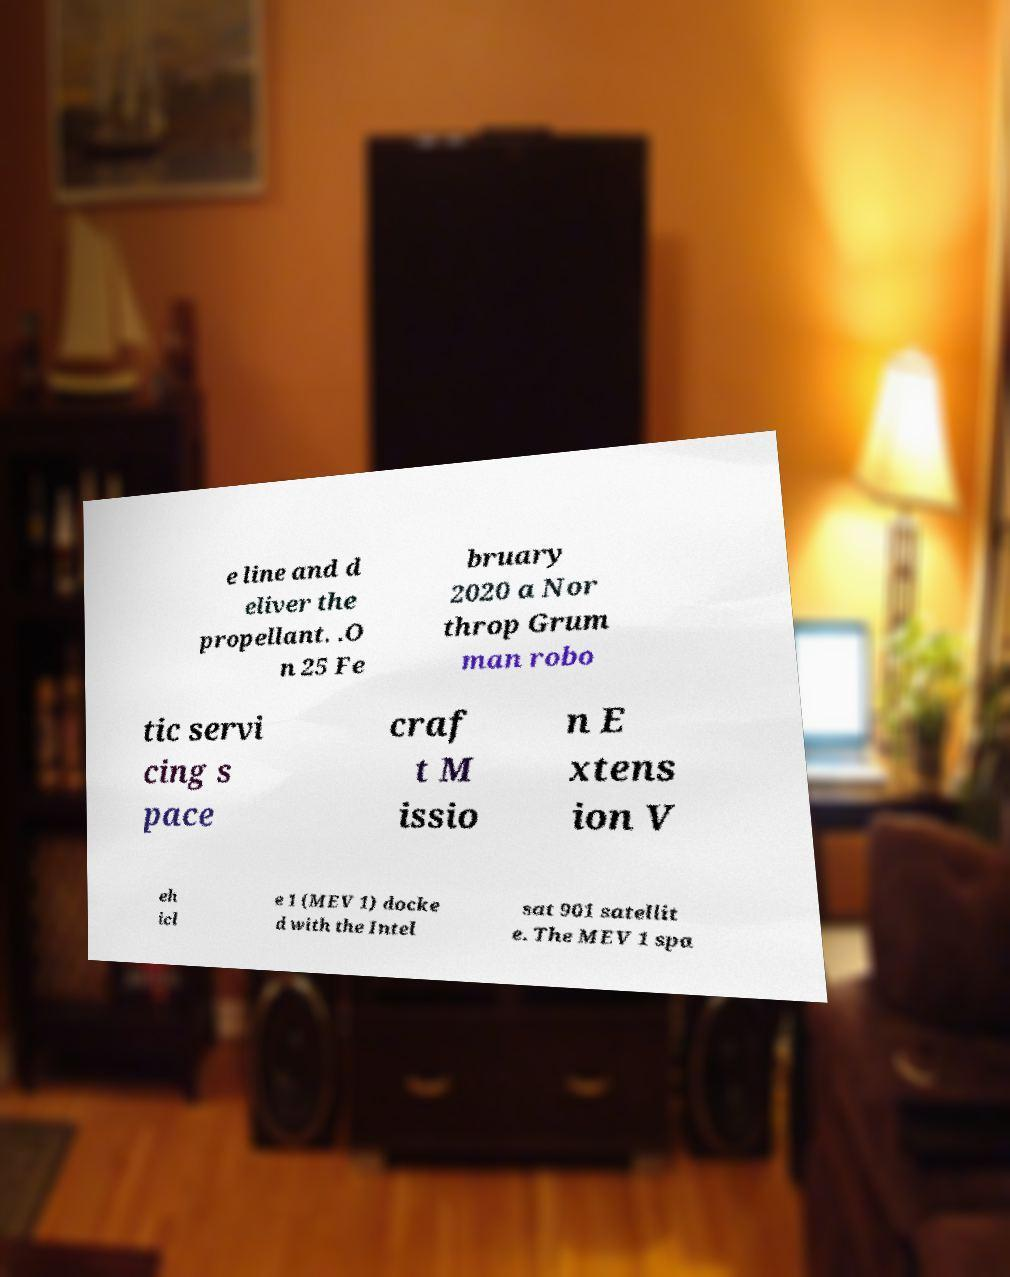There's text embedded in this image that I need extracted. Can you transcribe it verbatim? e line and d eliver the propellant. .O n 25 Fe bruary 2020 a Nor throp Grum man robo tic servi cing s pace craf t M issio n E xtens ion V eh icl e 1 (MEV 1) docke d with the Intel sat 901 satellit e. The MEV 1 spa 